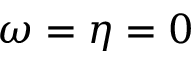<formula> <loc_0><loc_0><loc_500><loc_500>\omega = \eta = 0</formula> 